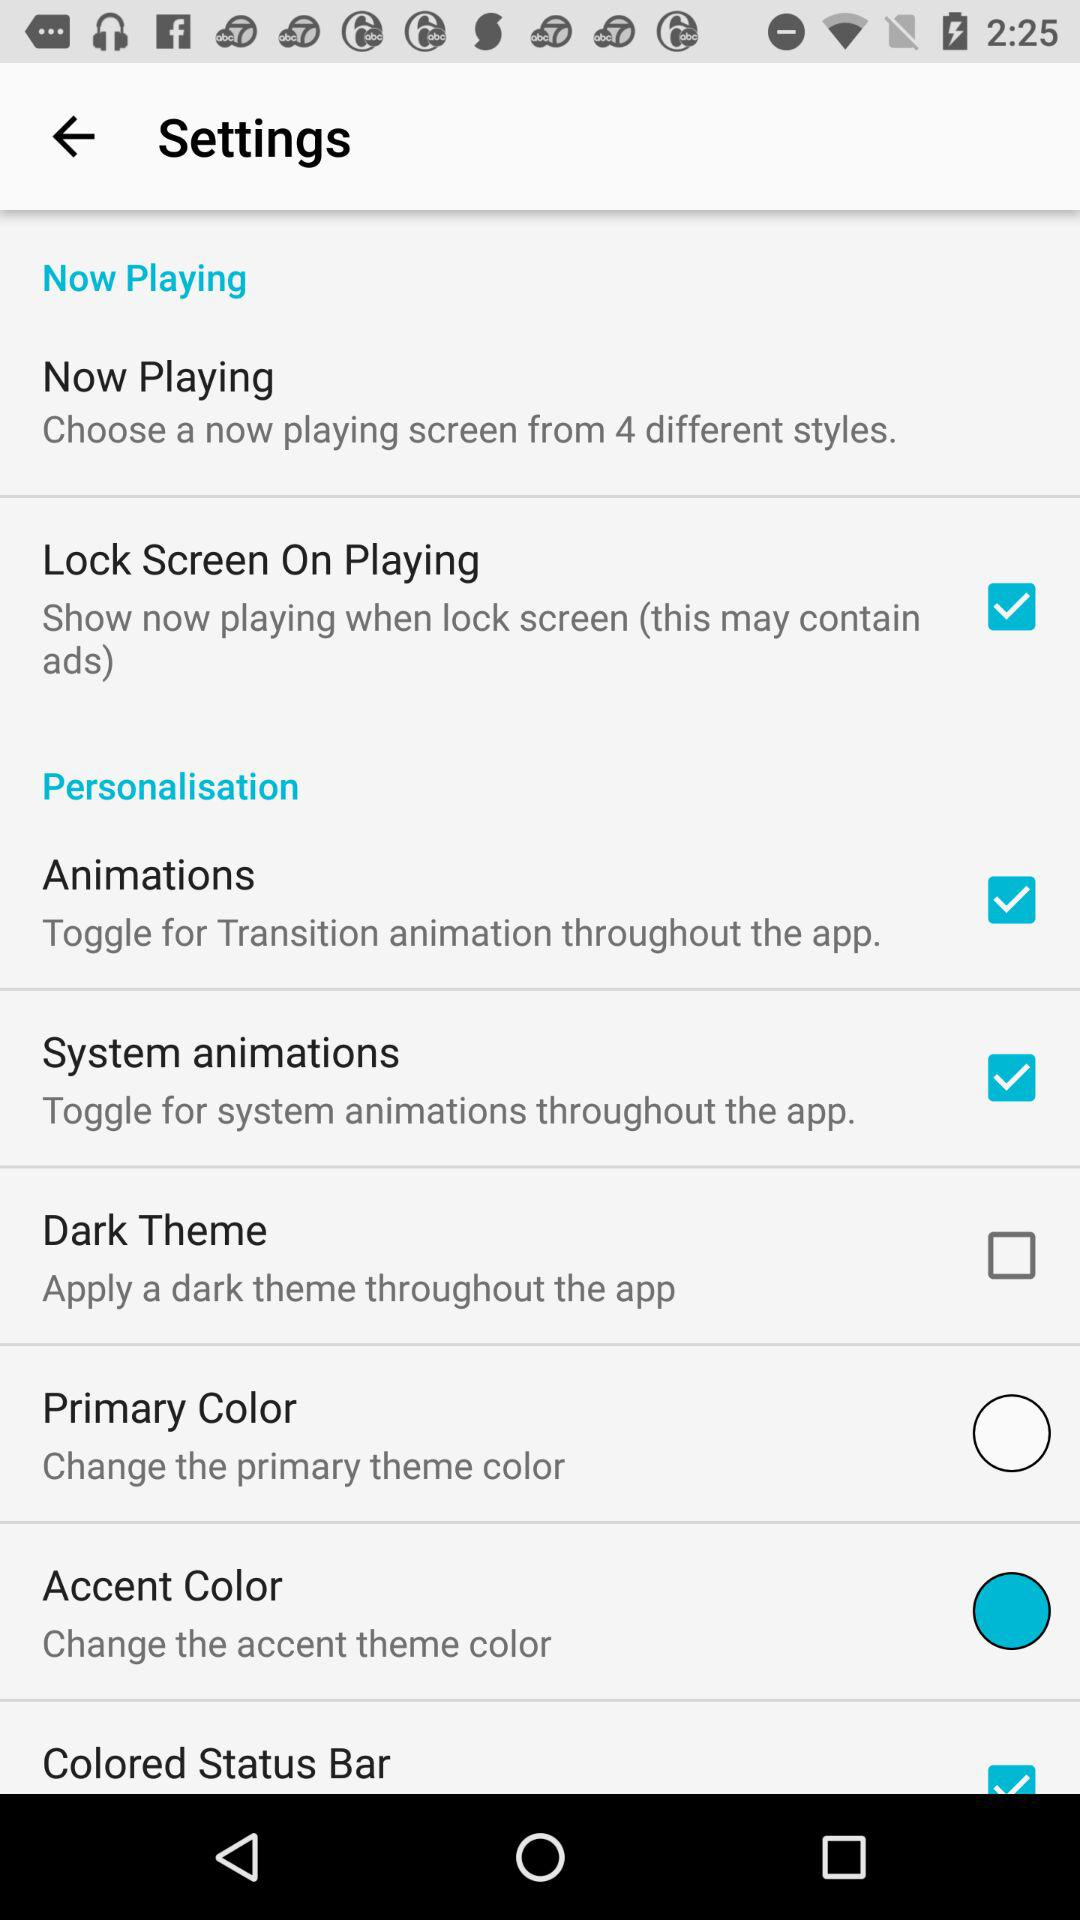What are the checked options? The checked options are "Lock Screen On Playing", "Animations", "System animations" and "Colored Status Bar". 